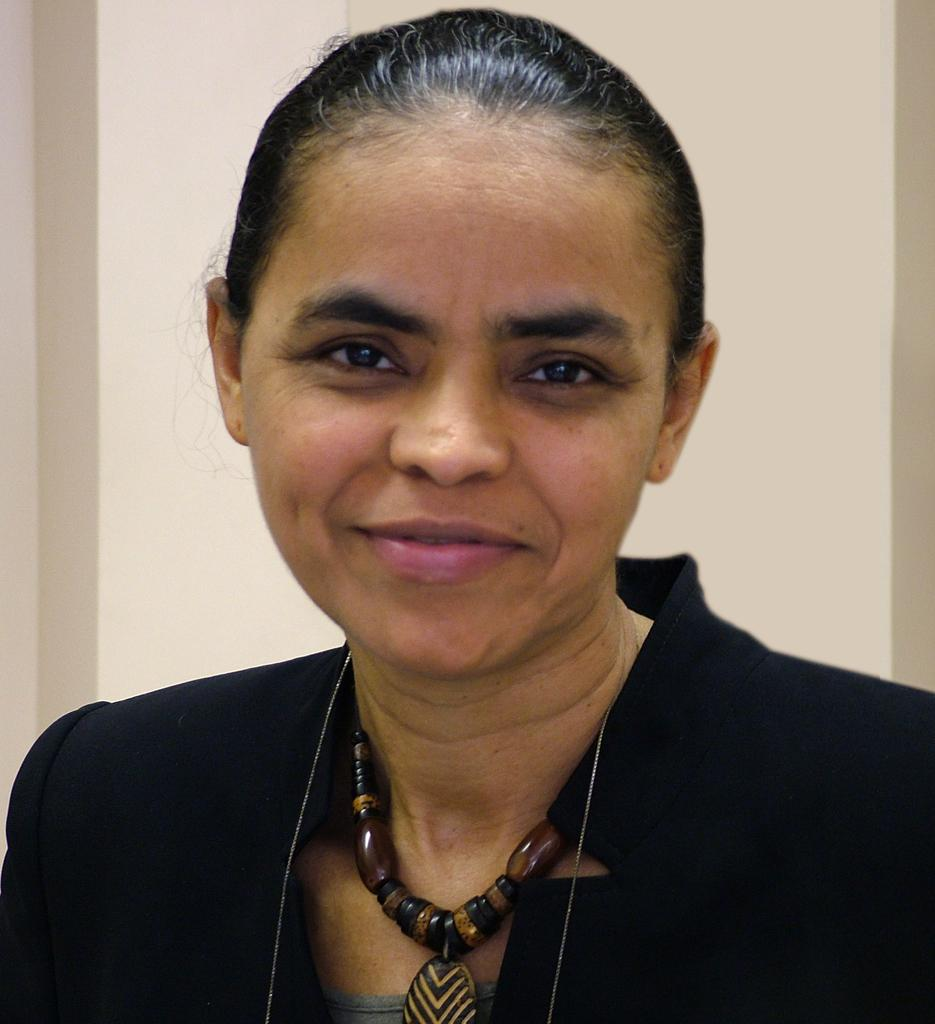What is the color of the background in the image? The background of the picture is in cream color. Who is present in the image? There is a woman in the image. What is the woman wearing around her neck? The woman is wearing a chain around her neck. What is the woman's facial expression in the image? The woman is smiling. Can you see any wings on the woman in the image? No, there are no wings visible on the woman in the image. 